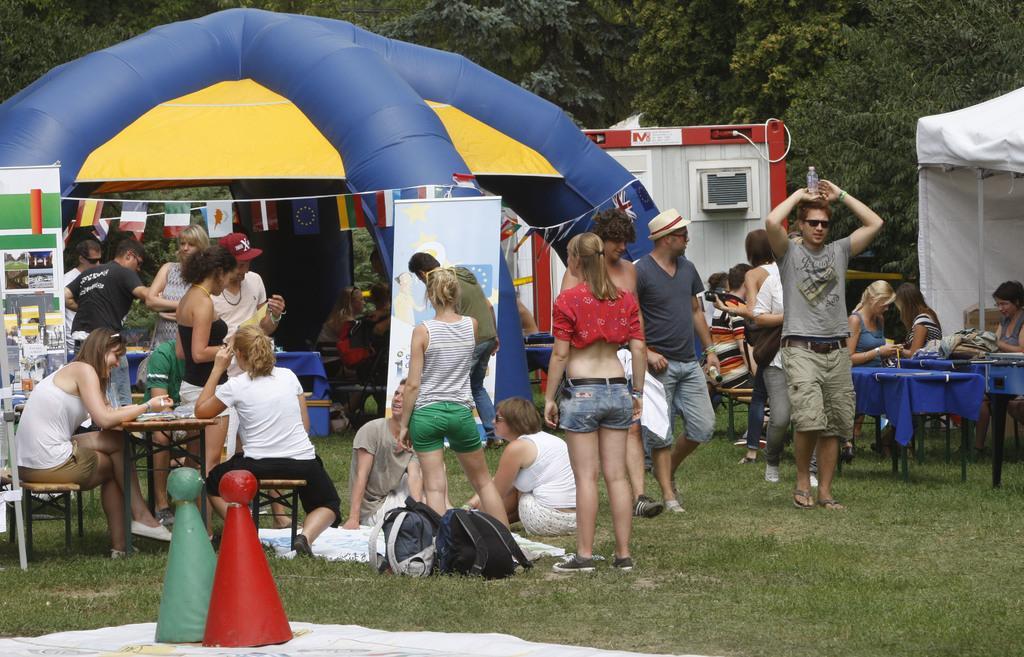Describe this image in one or two sentences. In this image I can see some are sitting on the chairs, some are walking and some are standing. In the background I can see trees. On the top left of the image I can see a air balloon. On the right side of the image I can see a white color tint. In the middle of the image there are some bags beside the person's. It seems to be like a playing area. At the back of air balloon there is a shed. On the left side of the image there is a rack and some objects are placed in it. 